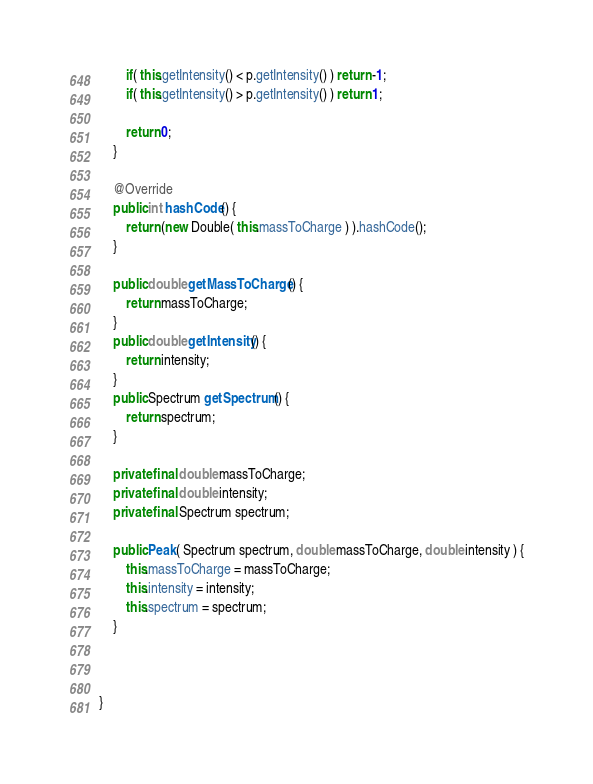Convert code to text. <code><loc_0><loc_0><loc_500><loc_500><_Java_>		if( this.getIntensity() < p.getIntensity() ) return -1;
		if( this.getIntensity() > p.getIntensity() ) return 1;
		
		return 0;
	}
	
	@Override
	public int hashCode() {
		return (new Double( this.massToCharge ) ).hashCode();
	}
	
	public double getMassToCharge() {
		return massToCharge;
	}
	public double getIntensity() {
		return intensity;
	}
	public Spectrum getSpectrum() {
		return spectrum;
	}
	
	private final double massToCharge;
	private final double intensity;
	private final Spectrum spectrum;
	
	public Peak( Spectrum spectrum, double massToCharge, double intensity ) {
		this.massToCharge = massToCharge;
		this.intensity = intensity;
		this.spectrum = spectrum;
	}


	
}
</code> 